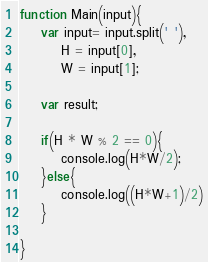<code> <loc_0><loc_0><loc_500><loc_500><_JavaScript_>function Main(input){
	var input= input.split(' '),
		H = input[0],
		W = input[1];

	var result;

	if(H * W % 2 == 0){
		console.log(H*W/2);
	}else{
		console.log((H*W+1)/2)
	}

}</code> 